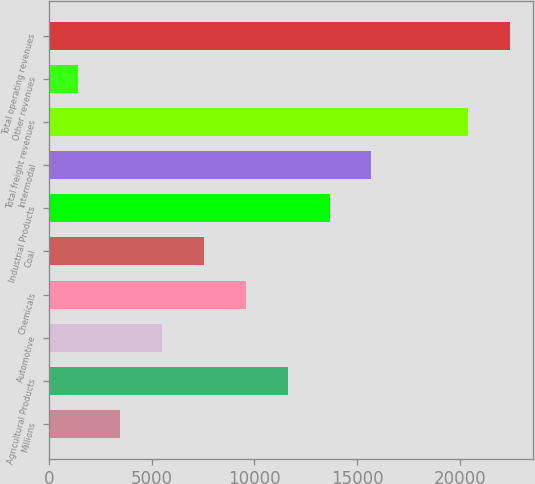<chart> <loc_0><loc_0><loc_500><loc_500><bar_chart><fcel>Millions<fcel>Agricultural Products<fcel>Automotive<fcel>Chemicals<fcel>Coal<fcel>Industrial Products<fcel>Intermodal<fcel>Total freight revenues<fcel>Other revenues<fcel>Total operating revenues<nl><fcel>3455.7<fcel>11614.5<fcel>5495.4<fcel>9574.8<fcel>7535.1<fcel>13654.2<fcel>15693.9<fcel>20397<fcel>1416<fcel>22436.7<nl></chart> 